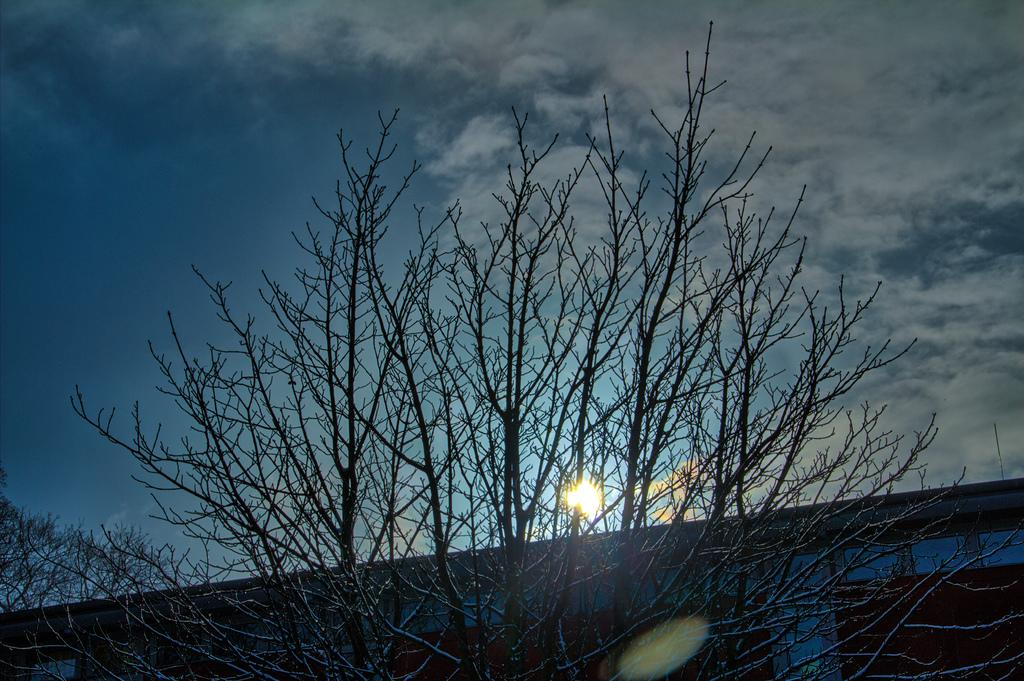What type of structure is present in the image? There is a building in the image. What type of natural vegetation is visible in the image? There are trees in the image. What celestial body is visible in the image? The sun is visible in the image. What part of the natural environment is visible in the image? The sky is visible in the image. What type of weather can be inferred from the image? The presence of clouds in the sky suggests that the weather might be partly cloudy. What type of glove is being traded by the coach in the image? There is no glove, trade, or coach present in the image. What type of vehicle is the coach driving in the image? There is no coach or vehicle present in the image. 